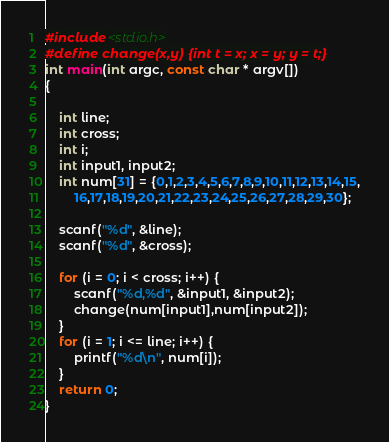<code> <loc_0><loc_0><loc_500><loc_500><_C_>#include <stdio.h>
#define change(x,y) {int t = x; x = y; y = t;}
int main(int argc, const char * argv[])
{

    int line;
    int cross;
    int i;
    int input1, input2;
    int num[31] = {0,1,2,3,4,5,6,7,8,9,10,11,12,13,14,15,
        16,17,18,19,20,21,22,23,24,25,26,27,28,29,30};
    
    scanf("%d", &line);
    scanf("%d", &cross);
    
    for (i = 0; i < cross; i++) {
        scanf("%d,%d", &input1, &input2);
        change(num[input1],num[input2]);
    }
    for (i = 1; i <= line; i++) {
        printf("%d\n", num[i]);
    }
    return 0;
}</code> 